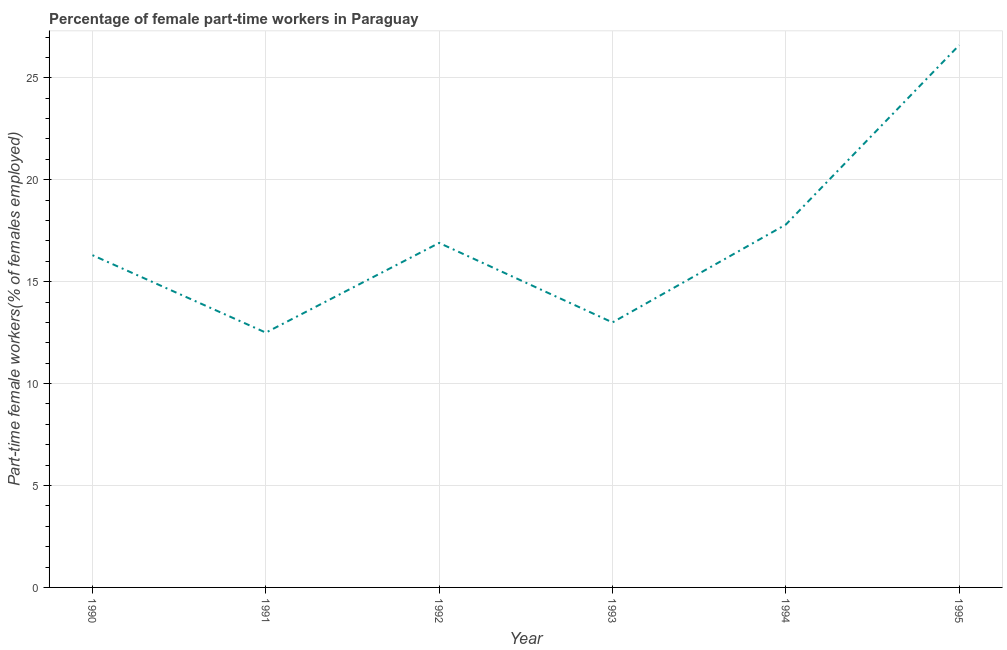What is the percentage of part-time female workers in 1990?
Your answer should be very brief. 16.3. Across all years, what is the maximum percentage of part-time female workers?
Your response must be concise. 26.6. In which year was the percentage of part-time female workers maximum?
Give a very brief answer. 1995. In which year was the percentage of part-time female workers minimum?
Your answer should be very brief. 1991. What is the sum of the percentage of part-time female workers?
Ensure brevity in your answer.  103.1. What is the average percentage of part-time female workers per year?
Ensure brevity in your answer.  17.18. What is the median percentage of part-time female workers?
Ensure brevity in your answer.  16.6. What is the ratio of the percentage of part-time female workers in 1993 to that in 1994?
Your answer should be very brief. 0.73. Is the percentage of part-time female workers in 1990 less than that in 1995?
Offer a very short reply. Yes. Is the difference between the percentage of part-time female workers in 1990 and 1991 greater than the difference between any two years?
Provide a short and direct response. No. What is the difference between the highest and the second highest percentage of part-time female workers?
Offer a terse response. 8.8. What is the difference between the highest and the lowest percentage of part-time female workers?
Offer a very short reply. 14.1. In how many years, is the percentage of part-time female workers greater than the average percentage of part-time female workers taken over all years?
Ensure brevity in your answer.  2. Does the percentage of part-time female workers monotonically increase over the years?
Make the answer very short. No. Are the values on the major ticks of Y-axis written in scientific E-notation?
Your answer should be compact. No. Does the graph contain grids?
Provide a succinct answer. Yes. What is the title of the graph?
Offer a very short reply. Percentage of female part-time workers in Paraguay. What is the label or title of the Y-axis?
Your response must be concise. Part-time female workers(% of females employed). What is the Part-time female workers(% of females employed) of 1990?
Provide a short and direct response. 16.3. What is the Part-time female workers(% of females employed) of 1992?
Make the answer very short. 16.9. What is the Part-time female workers(% of females employed) of 1994?
Offer a terse response. 17.8. What is the Part-time female workers(% of females employed) in 1995?
Ensure brevity in your answer.  26.6. What is the difference between the Part-time female workers(% of females employed) in 1990 and 1994?
Offer a terse response. -1.5. What is the difference between the Part-time female workers(% of females employed) in 1990 and 1995?
Ensure brevity in your answer.  -10.3. What is the difference between the Part-time female workers(% of females employed) in 1991 and 1993?
Ensure brevity in your answer.  -0.5. What is the difference between the Part-time female workers(% of females employed) in 1991 and 1995?
Give a very brief answer. -14.1. What is the difference between the Part-time female workers(% of females employed) in 1992 and 1993?
Offer a very short reply. 3.9. What is the difference between the Part-time female workers(% of females employed) in 1992 and 1994?
Ensure brevity in your answer.  -0.9. What is the difference between the Part-time female workers(% of females employed) in 1992 and 1995?
Give a very brief answer. -9.7. What is the difference between the Part-time female workers(% of females employed) in 1993 and 1994?
Make the answer very short. -4.8. What is the difference between the Part-time female workers(% of females employed) in 1994 and 1995?
Provide a succinct answer. -8.8. What is the ratio of the Part-time female workers(% of females employed) in 1990 to that in 1991?
Your answer should be very brief. 1.3. What is the ratio of the Part-time female workers(% of females employed) in 1990 to that in 1992?
Offer a very short reply. 0.96. What is the ratio of the Part-time female workers(% of females employed) in 1990 to that in 1993?
Give a very brief answer. 1.25. What is the ratio of the Part-time female workers(% of females employed) in 1990 to that in 1994?
Keep it short and to the point. 0.92. What is the ratio of the Part-time female workers(% of females employed) in 1990 to that in 1995?
Make the answer very short. 0.61. What is the ratio of the Part-time female workers(% of females employed) in 1991 to that in 1992?
Your answer should be compact. 0.74. What is the ratio of the Part-time female workers(% of females employed) in 1991 to that in 1994?
Provide a succinct answer. 0.7. What is the ratio of the Part-time female workers(% of females employed) in 1991 to that in 1995?
Offer a terse response. 0.47. What is the ratio of the Part-time female workers(% of females employed) in 1992 to that in 1994?
Your answer should be compact. 0.95. What is the ratio of the Part-time female workers(% of females employed) in 1992 to that in 1995?
Make the answer very short. 0.64. What is the ratio of the Part-time female workers(% of females employed) in 1993 to that in 1994?
Your answer should be very brief. 0.73. What is the ratio of the Part-time female workers(% of females employed) in 1993 to that in 1995?
Keep it short and to the point. 0.49. What is the ratio of the Part-time female workers(% of females employed) in 1994 to that in 1995?
Provide a succinct answer. 0.67. 